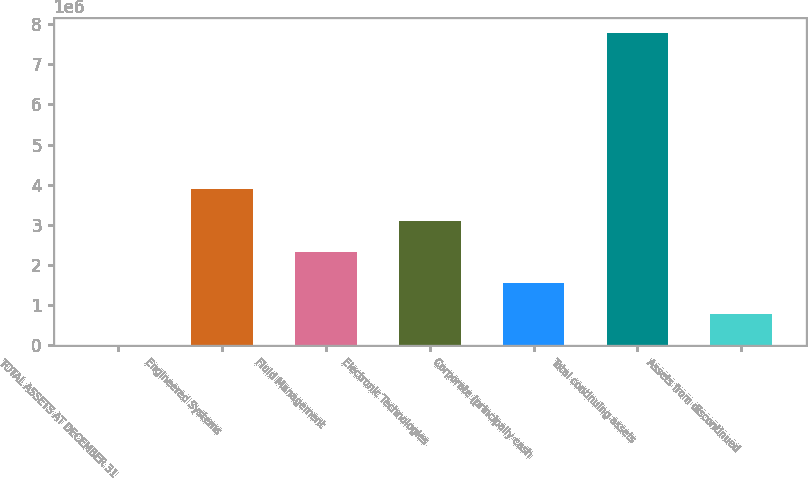<chart> <loc_0><loc_0><loc_500><loc_500><bar_chart><fcel>TOTAL ASSETS AT DECEMBER 31<fcel>Engineered Systems<fcel>Fluid Management<fcel>Electronic Technologies<fcel>Corporate (principally cash<fcel>Total continuing assets<fcel>Assets from discontinued<nl><fcel>2009<fcel>3.88386e+06<fcel>2.33112e+06<fcel>3.10749e+06<fcel>1.55475e+06<fcel>7.7657e+06<fcel>778378<nl></chart> 